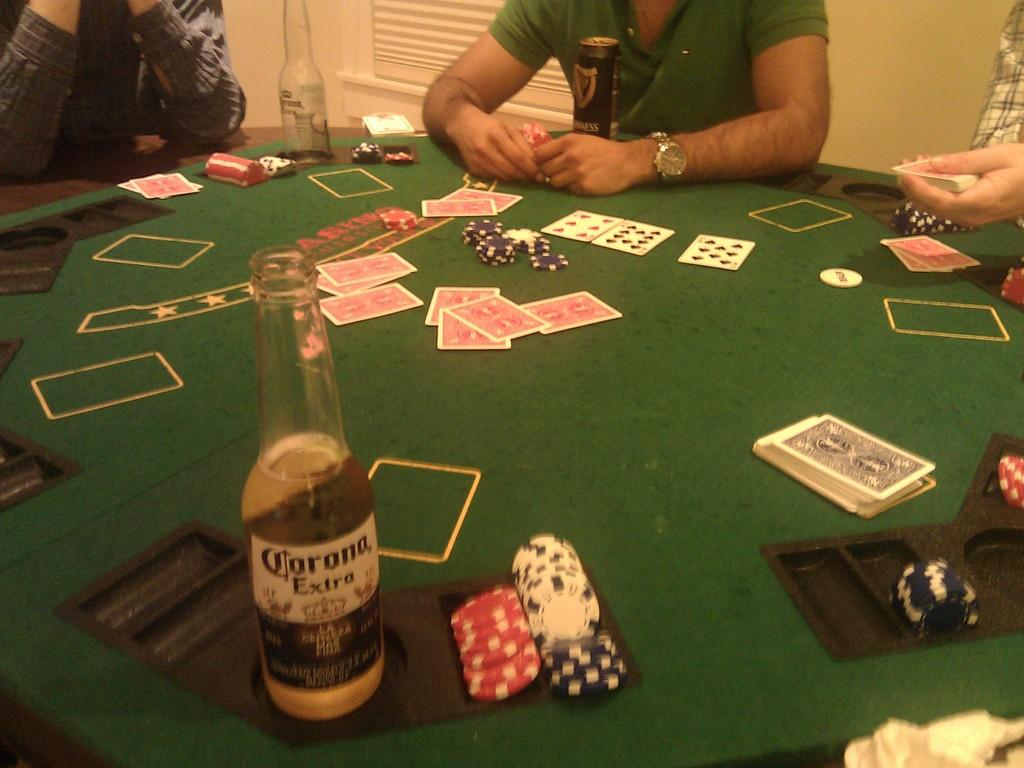What type of objects can be seen in the image? There are cards, coins, and a wine-bottle in the image. What is the color of the table in the image? The table in the image is green. Are there any people present in the image? Yes, there are people sitting around the table in the image. What is the color of the wall in the image? The wall in the image is cream-colored. What type of slope can be seen in the image? There is no slope present in the image. Is there a gate visible in the image? There is no gate present in the image. 